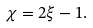Convert formula to latex. <formula><loc_0><loc_0><loc_500><loc_500>\chi = 2 \xi - 1 .</formula> 